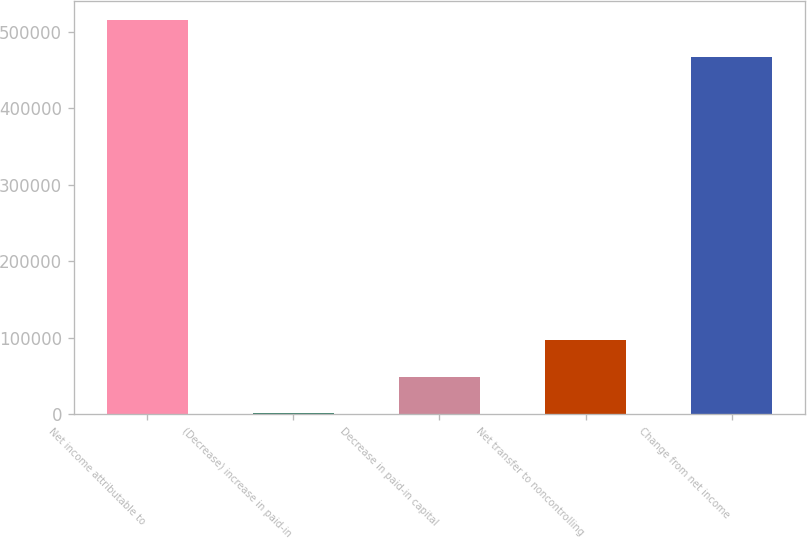<chart> <loc_0><loc_0><loc_500><loc_500><bar_chart><fcel>Net income attributable to<fcel>(Decrease) increase in paid-in<fcel>Decrease in paid-in capital<fcel>Net transfer to noncontrolling<fcel>Change from net income<nl><fcel>514886<fcel>1299<fcel>48969.2<fcel>96639.4<fcel>467216<nl></chart> 